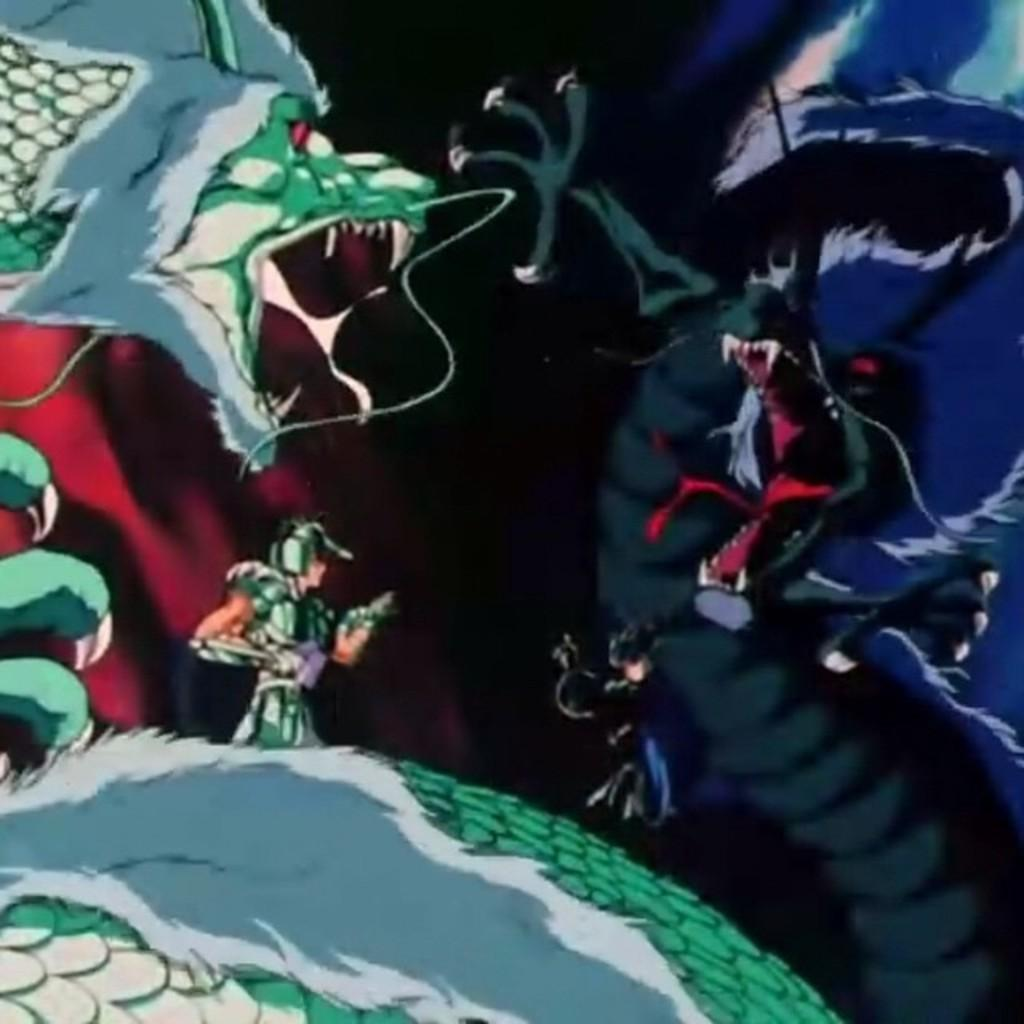What type of image is being described? The image is an animated picture. What creatures are present in the image? There are dragons in the image. Are there any human figures in the image? Yes, there is a person in the image. What book is the person reading while sitting on the swing in the image? There is no book or swing present in the image; it features animated dragons and a person. What is the size of the dragons in the image? The size of the dragons cannot be determined from the image alone, as there is no reference point for comparison. 